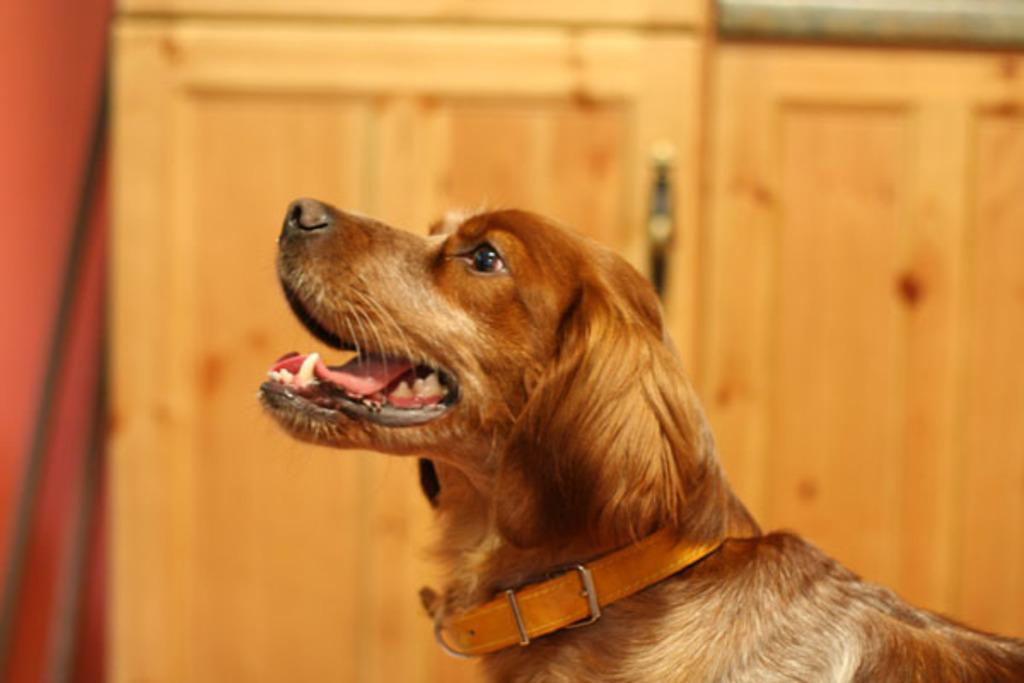What type of animal is in the image? There is a dog in the image. Can you describe the dog's appearance? The dog is wearing a collar. What can be observed about the background of the image? The background of the image is blurry. What type of objects are present in the image? There are wooden objects in the image. How does the giraffe participate in the competition in the image? There is no giraffe or competition present in the image. What type of expression does the dog have on its face in the image? The provided facts do not mention the dog's facial expression, so we cannot determine if the dog is smiling or not. 